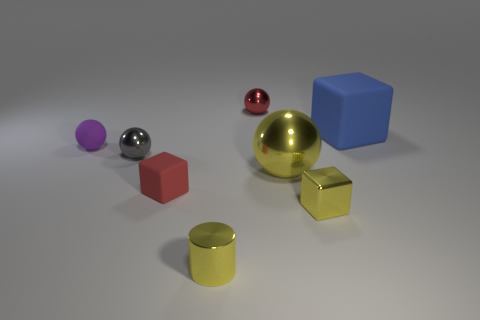Subtract all purple spheres. How many spheres are left? 3 Subtract all purple spheres. How many spheres are left? 3 Subtract all cyan spheres. Subtract all yellow cubes. How many spheres are left? 4 Add 2 big metallic balls. How many objects exist? 10 Subtract all cylinders. How many objects are left? 7 Subtract 1 yellow cubes. How many objects are left? 7 Subtract all metal balls. Subtract all small red rubber objects. How many objects are left? 4 Add 1 metal blocks. How many metal blocks are left? 2 Add 1 tiny gray metallic objects. How many tiny gray metallic objects exist? 2 